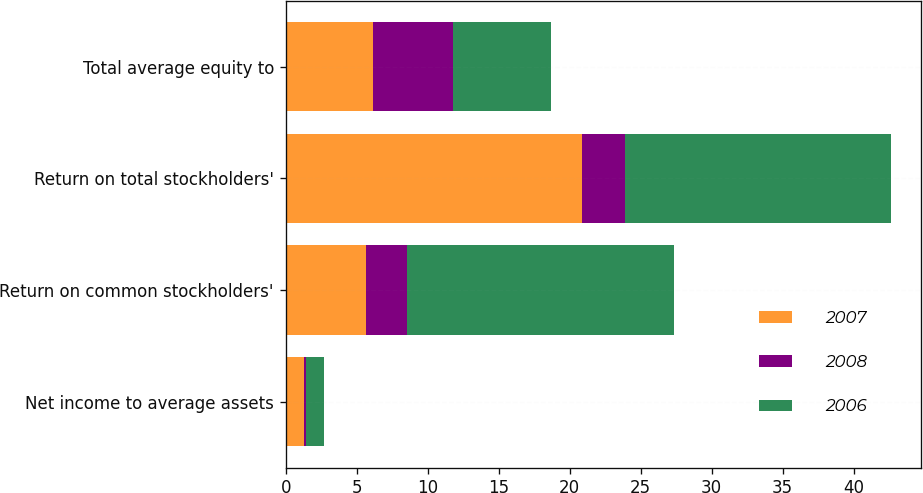Convert chart to OTSL. <chart><loc_0><loc_0><loc_500><loc_500><stacked_bar_chart><ecel><fcel>Net income to average assets<fcel>Return on common stockholders'<fcel>Return on total stockholders'<fcel>Total average equity to<nl><fcel>2007<fcel>1.28<fcel>5.66<fcel>20.9<fcel>6.12<nl><fcel>2008<fcel>0.17<fcel>2.9<fcel>3<fcel>5.66<nl><fcel>2006<fcel>1.28<fcel>18.8<fcel>18.7<fcel>6.87<nl></chart> 